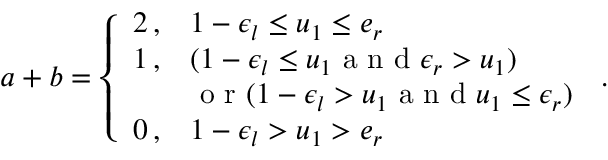Convert formula to latex. <formula><loc_0><loc_0><loc_500><loc_500>a + b = \left \{ \begin{array} { l l } { 2 \, , } & { 1 - \epsilon _ { l } \leq u _ { 1 } \leq e _ { r } } \\ { 1 \, , } & { ( 1 - \epsilon _ { l } \leq u _ { 1 } a n d \epsilon _ { r } > u _ { 1 } ) } & { o r ( 1 - \epsilon _ { l } > u _ { 1 } a n d u _ { 1 } \leq \epsilon _ { r } ) } \\ { 0 \, , } & { 1 - \epsilon _ { l } > u _ { 1 } > e _ { r } } \end{array} \, .</formula> 